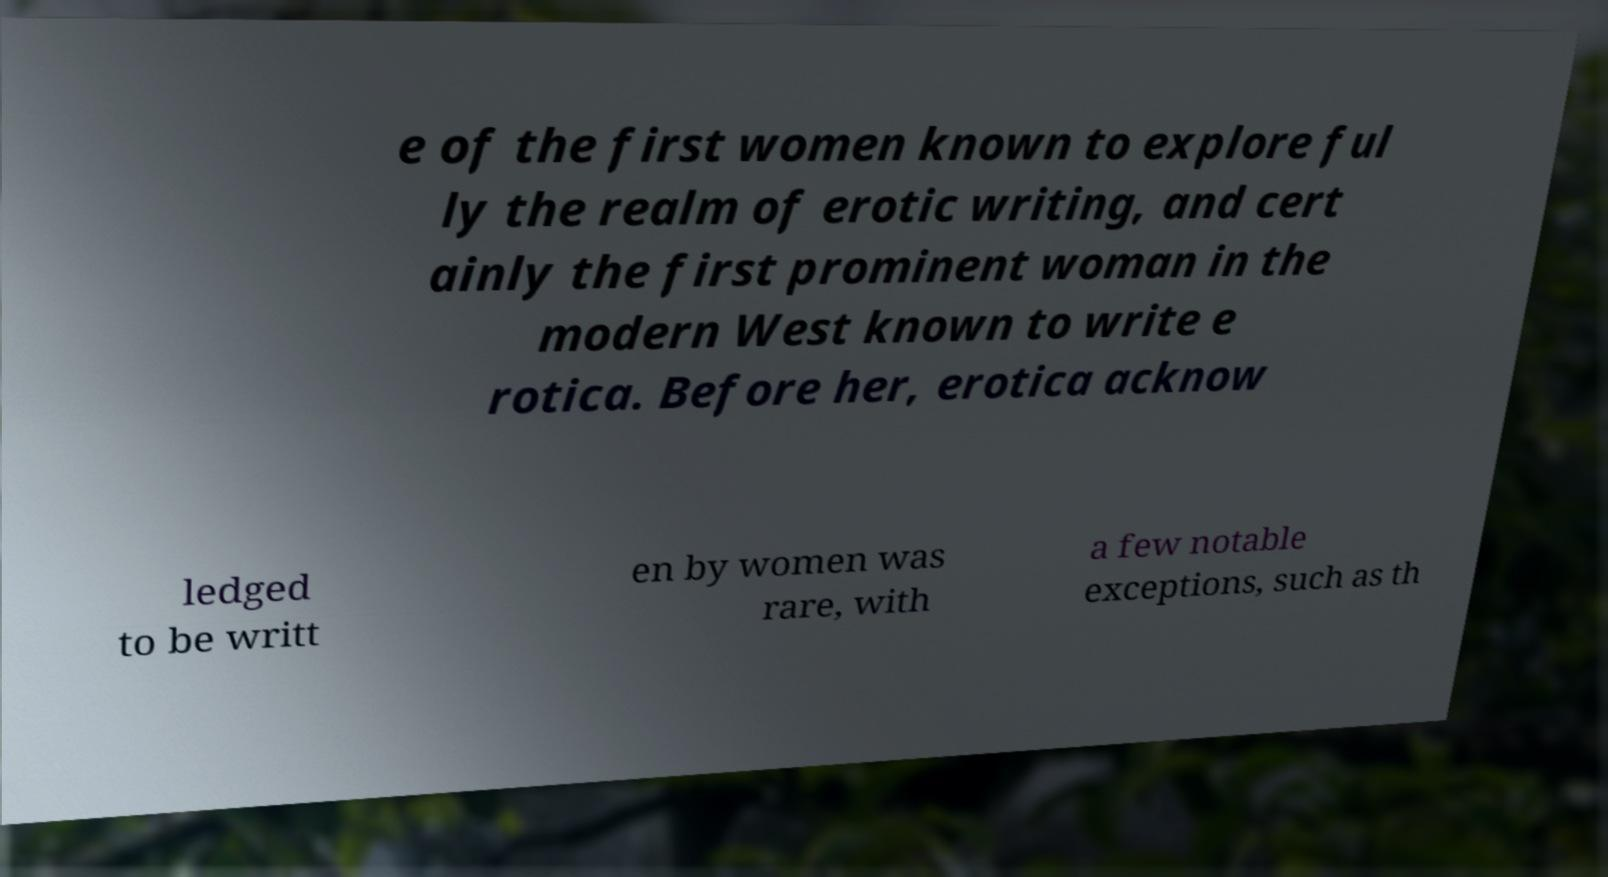There's text embedded in this image that I need extracted. Can you transcribe it verbatim? e of the first women known to explore ful ly the realm of erotic writing, and cert ainly the first prominent woman in the modern West known to write e rotica. Before her, erotica acknow ledged to be writt en by women was rare, with a few notable exceptions, such as th 